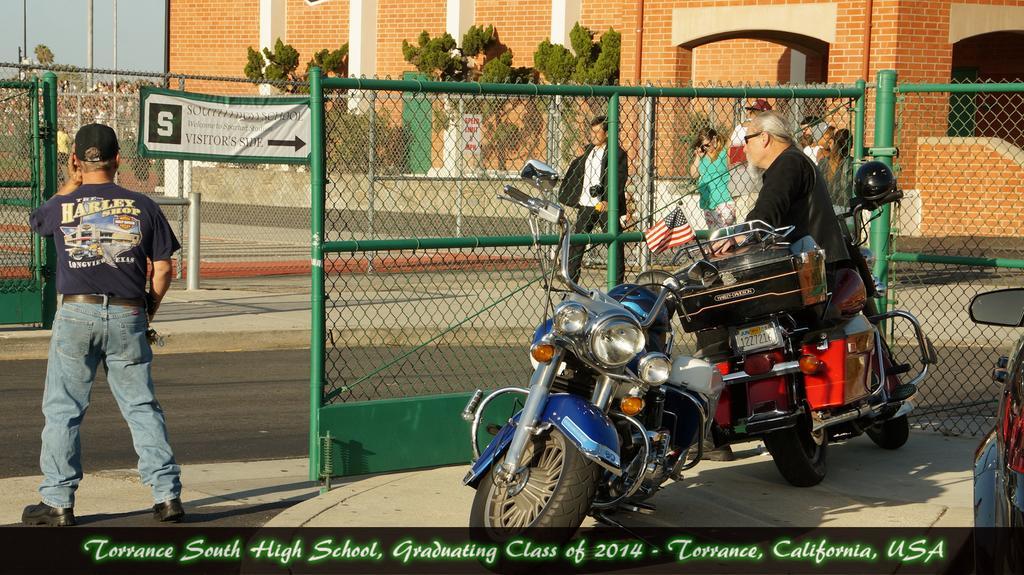How would you summarize this image in a sentence or two? In this image i can see a person standing in the left corner wearing a blue jeans, black shoe and t shirt, to the right of the image i can see 2 motor bikes and a person kneeling to one of the motor bike. On the background i can see sky , building , trees and some people walking. 